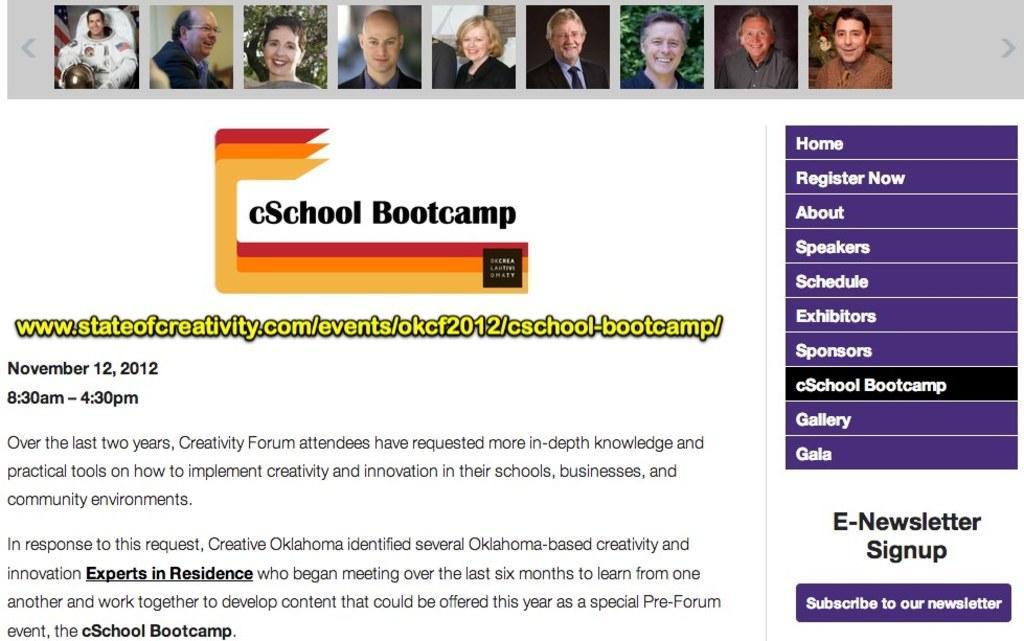Could you give a brief overview of what you see in this image? In this image I see few pictures over here and I see that few of them are smiling and I see words and numbers written over here and it is white in the background. 